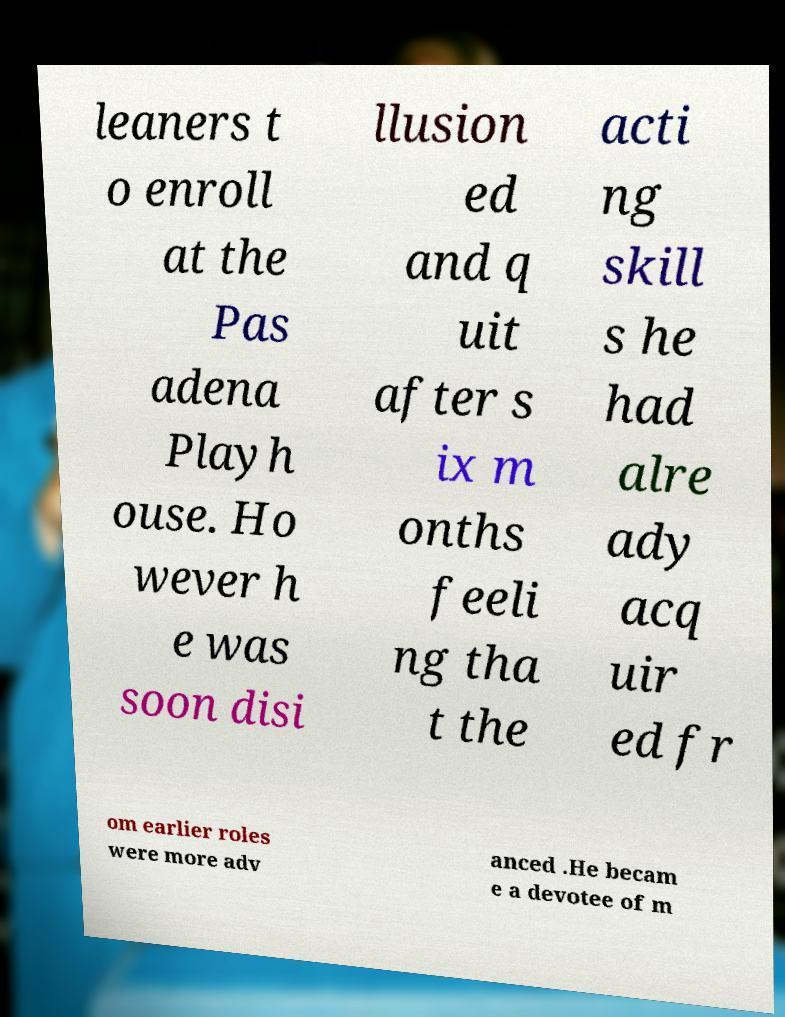Can you read and provide the text displayed in the image?This photo seems to have some interesting text. Can you extract and type it out for me? leaners t o enroll at the Pas adena Playh ouse. Ho wever h e was soon disi llusion ed and q uit after s ix m onths feeli ng tha t the acti ng skill s he had alre ady acq uir ed fr om earlier roles were more adv anced .He becam e a devotee of m 